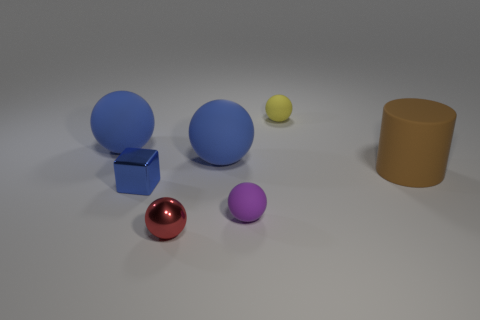There is a shiny thing that is behind the tiny red shiny thing; what shape is it?
Make the answer very short. Cube. What is the color of the big thing that is on the right side of the tiny rubber ball behind the tiny blue thing?
Ensure brevity in your answer.  Brown. What number of things are tiny balls that are on the right side of the tiny purple sphere or blocks?
Offer a terse response. 2. Do the purple matte thing and the blue rubber object on the left side of the small metal sphere have the same size?
Ensure brevity in your answer.  No. What number of large objects are yellow spheres or rubber cylinders?
Your answer should be compact. 1. The brown rubber object has what shape?
Your answer should be very brief. Cylinder. Is there a large cyan sphere made of the same material as the small blue thing?
Your answer should be very brief. No. Are there more blue balls than big objects?
Give a very brief answer. No. Is the purple thing made of the same material as the tiny yellow thing?
Your response must be concise. Yes. How many matte things are big cylinders or tiny blue blocks?
Your answer should be compact. 1. 